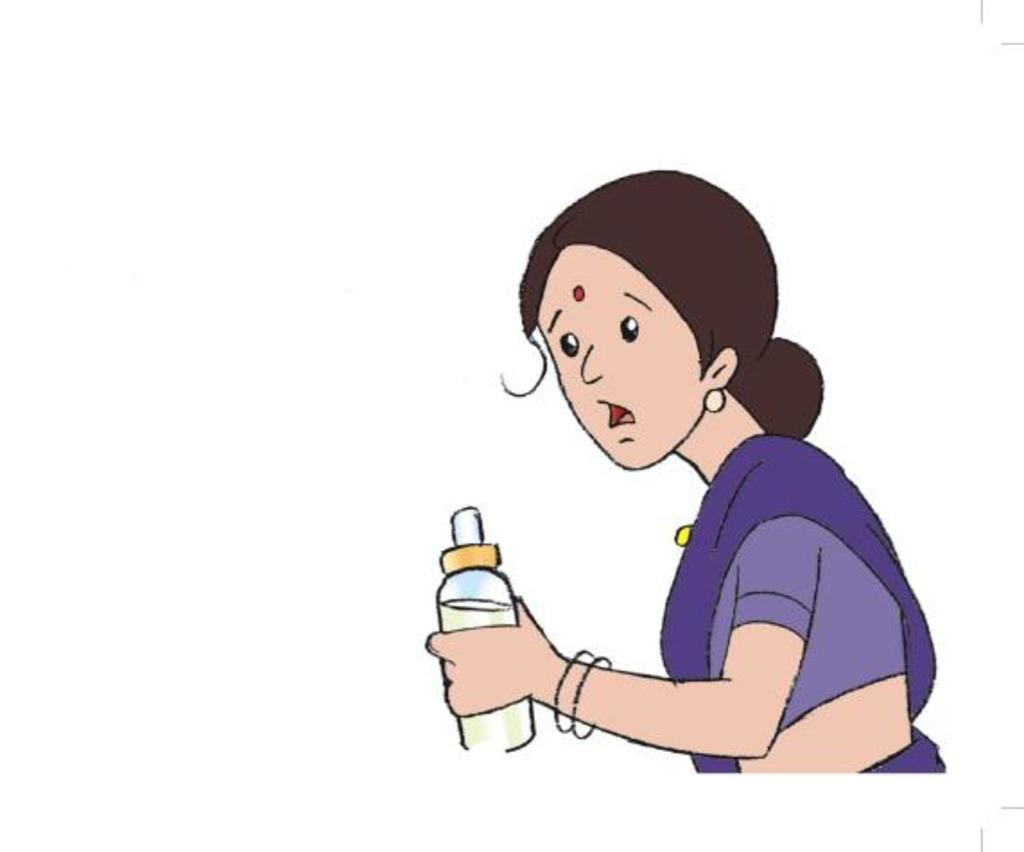What type of picture is featured in the image? The image contains a cartoon picture. What type of engine can be seen in the cartoon picture? There is no engine present in the cartoon picture; it is not mentioned in the provided facts. 